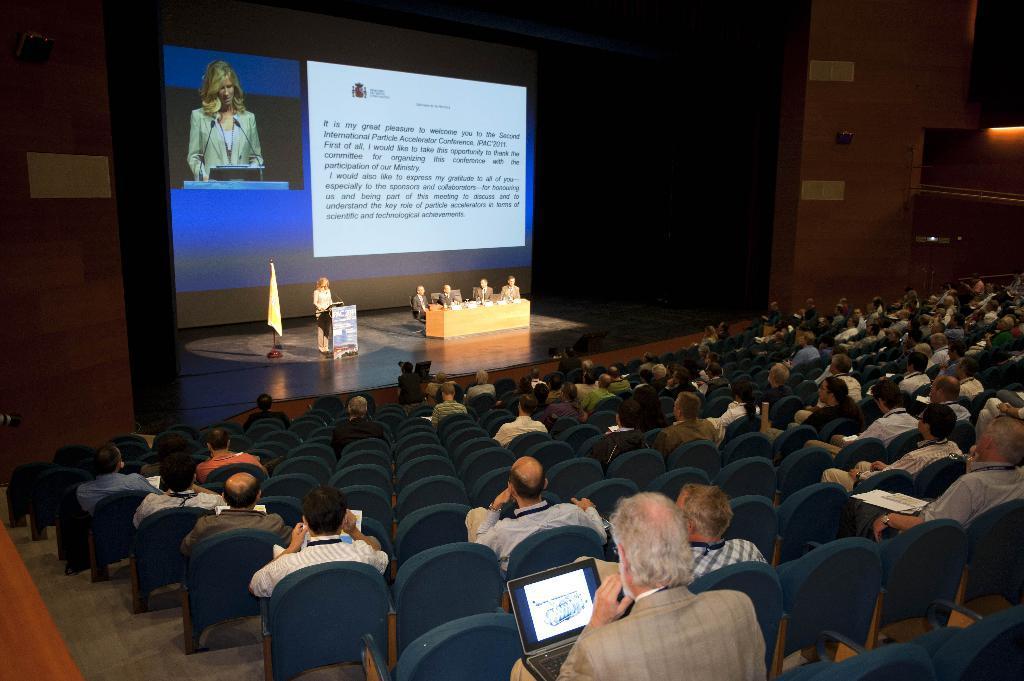Describe this image in one or two sentences. In this image there are group of people. On the stage there are four people sitting behind the table and there is a woman standing at the podium and there is a flag beside the woman. At the back there is a screen. This is the picture inside the auditorium. 